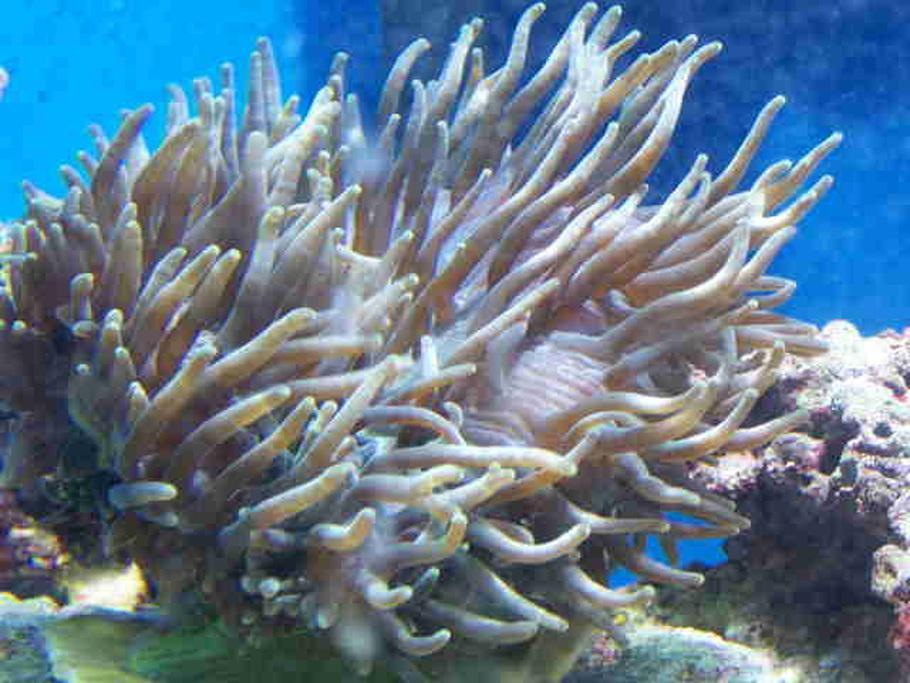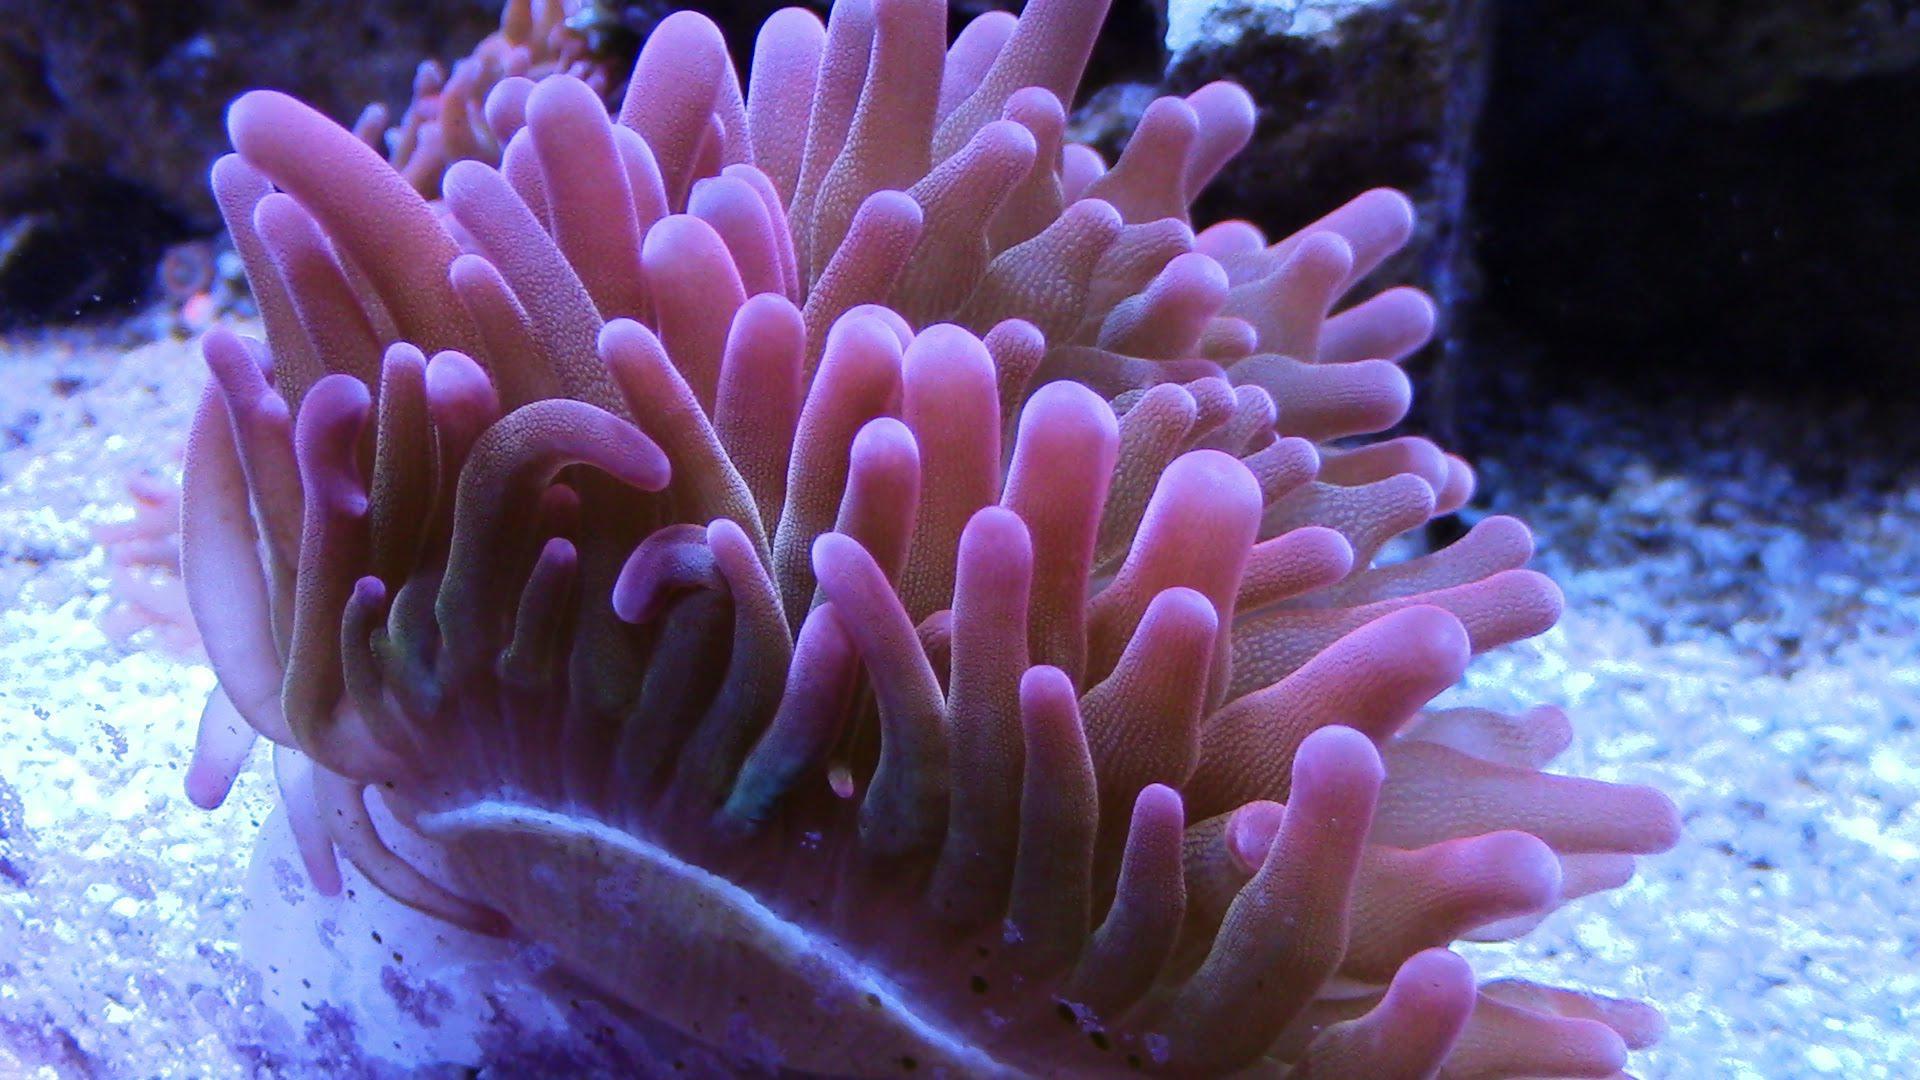The first image is the image on the left, the second image is the image on the right. Considering the images on both sides, is "No fish are swimming near anemone in at least one image, and in one image the anemone has tendrils that are at least partly purple, while the other image shows neutral-colored anemone." valid? Answer yes or no. Yes. The first image is the image on the left, the second image is the image on the right. Given the left and right images, does the statement "The left image has at least one fish with a single stripe near it's head swimming near an anemone" hold true? Answer yes or no. No. 